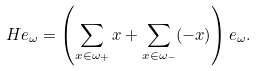<formula> <loc_0><loc_0><loc_500><loc_500>H e _ { \omega } = \left ( \sum _ { x \in \omega _ { + } } x + \sum _ { x \in \omega _ { - } } ( - x ) \right ) e _ { \omega } .</formula> 